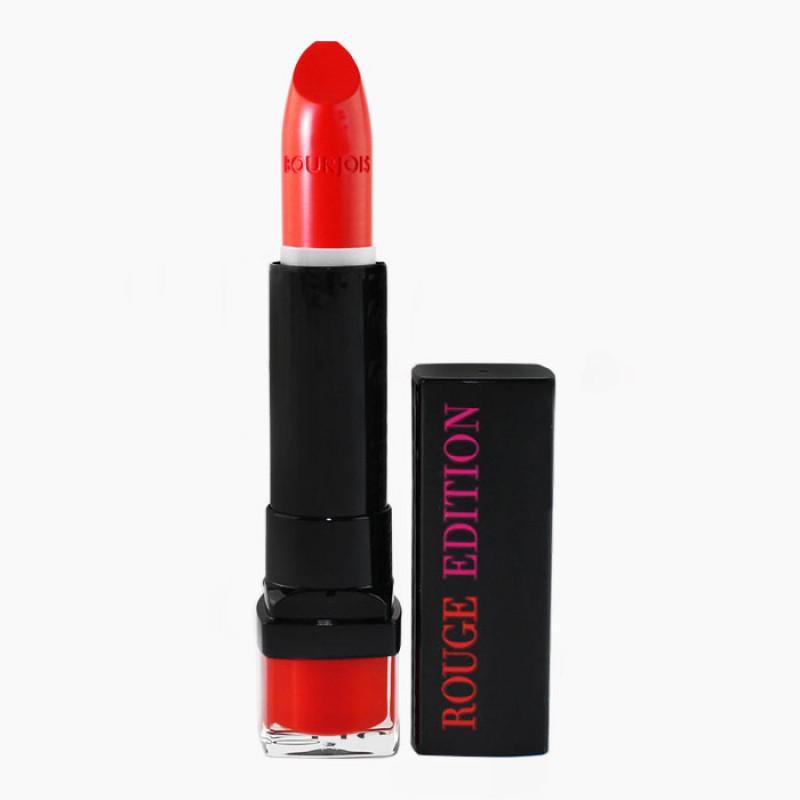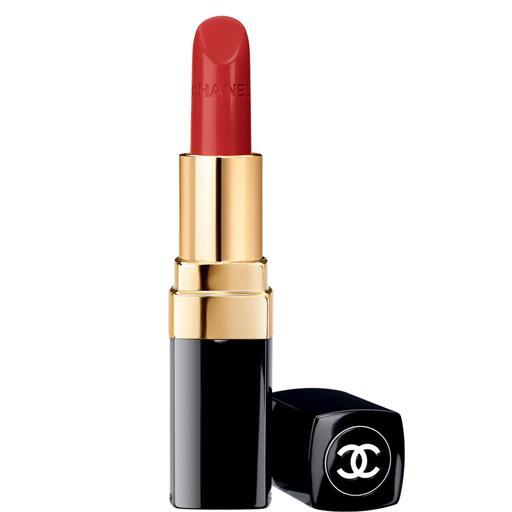The first image is the image on the left, the second image is the image on the right. For the images displayed, is the sentence "Images show a total of two red lipsticks with black caps." factually correct? Answer yes or no. Yes. The first image is the image on the left, the second image is the image on the right. Considering the images on both sides, is "Two lipsticks with the color extended stand beside the black cap of each tube." valid? Answer yes or no. Yes. 